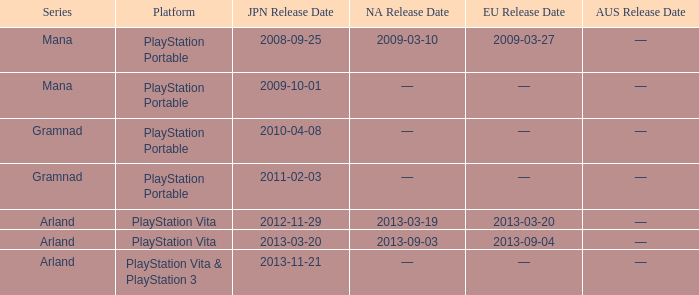What is the series with a North American release date on 2013-09-03? Arland. 